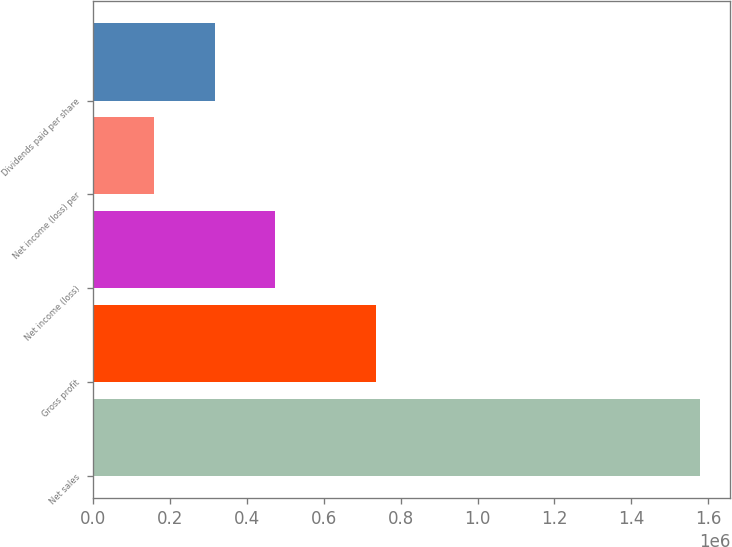Convert chart. <chart><loc_0><loc_0><loc_500><loc_500><bar_chart><fcel>Net sales<fcel>Gross profit<fcel>Net income (loss)<fcel>Net income (loss) per<fcel>Dividends paid per share<nl><fcel>1.57882e+06<fcel>735408<fcel>473648<fcel>157883<fcel>315765<nl></chart> 